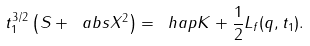Convert formula to latex. <formula><loc_0><loc_0><loc_500><loc_500>t _ { 1 } ^ { 3 / 2 } \left ( S + \ a b s { X } ^ { 2 } \right ) = \ h a p K + \frac { 1 } { 2 } L _ { f } ( q , t _ { 1 } ) .</formula> 